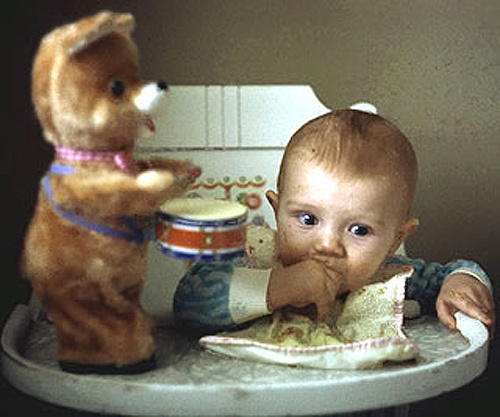Describe the objects in this image and their specific colors. I can see teddy bear in black, maroon, and gray tones and people in black, brown, gray, and tan tones in this image. 